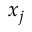<formula> <loc_0><loc_0><loc_500><loc_500>x _ { j }</formula> 